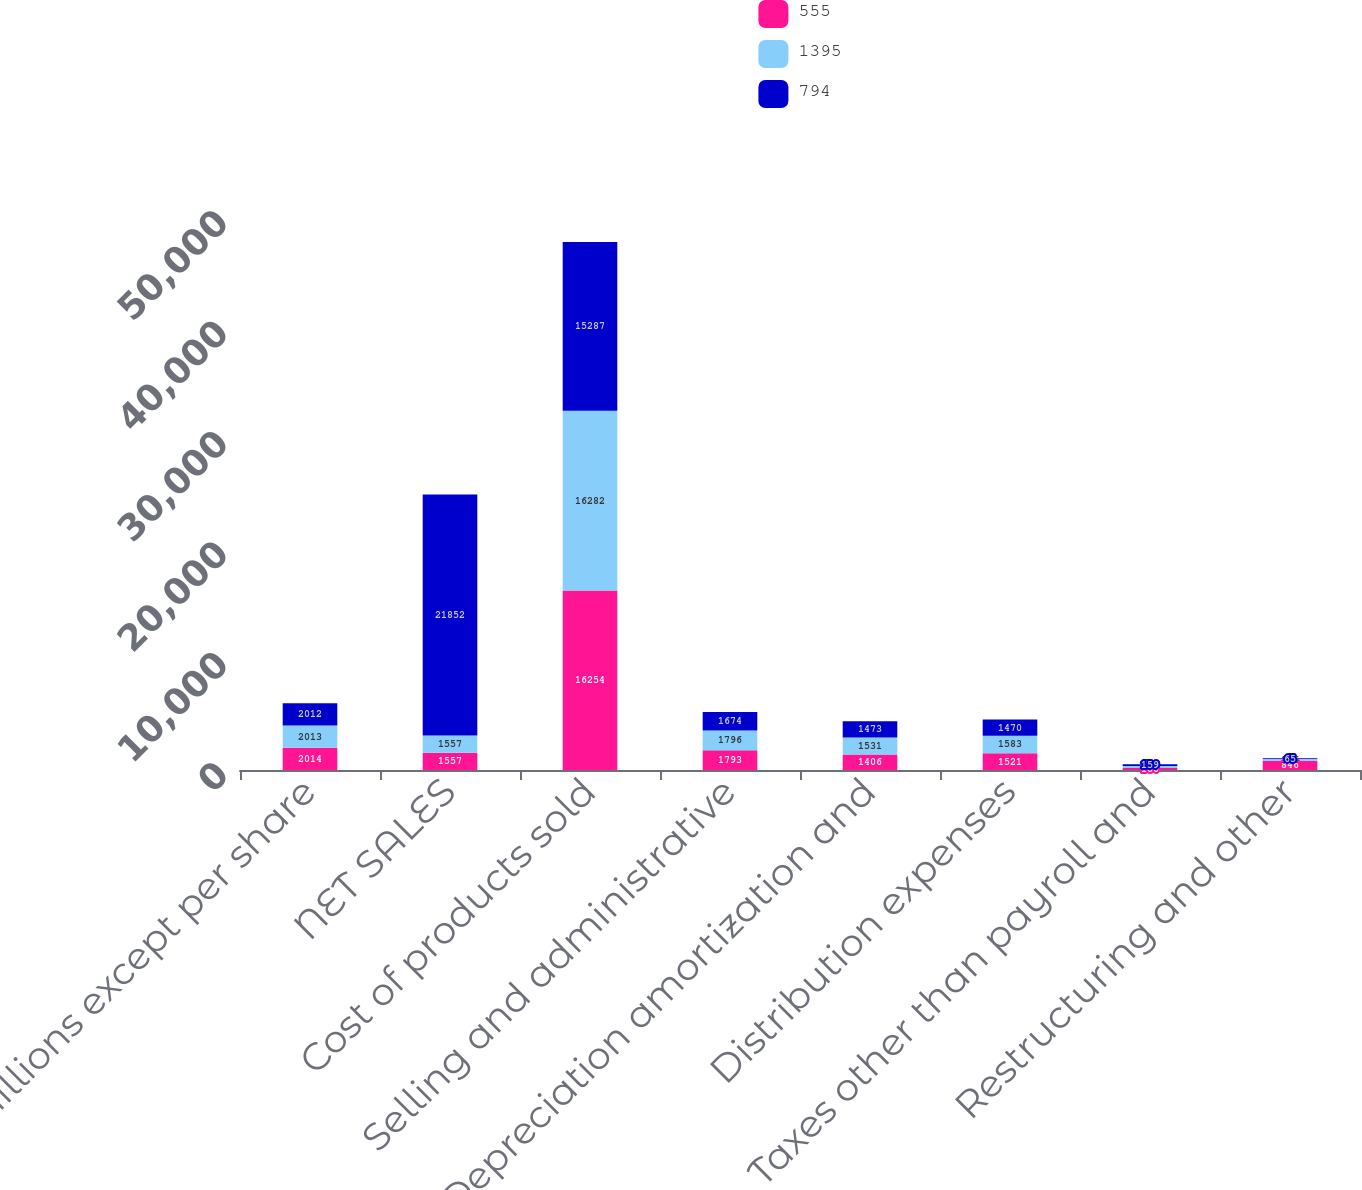Convert chart. <chart><loc_0><loc_0><loc_500><loc_500><stacked_bar_chart><ecel><fcel>In millions except per share<fcel>NET SALES<fcel>Cost of products sold<fcel>Selling and administrative<fcel>Depreciation amortization and<fcel>Distribution expenses<fcel>Taxes other than payroll and<fcel>Restructuring and other<nl><fcel>555<fcel>2014<fcel>1557<fcel>16254<fcel>1793<fcel>1406<fcel>1521<fcel>180<fcel>846<nl><fcel>1395<fcel>2013<fcel>1557<fcel>16282<fcel>1796<fcel>1531<fcel>1583<fcel>178<fcel>156<nl><fcel>794<fcel>2012<fcel>21852<fcel>15287<fcel>1674<fcel>1473<fcel>1470<fcel>159<fcel>65<nl></chart> 